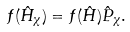<formula> <loc_0><loc_0><loc_500><loc_500>f ( \hat { H } _ { \chi } ) = f ( \hat { H } ) \hat { P } _ { \chi } .</formula> 